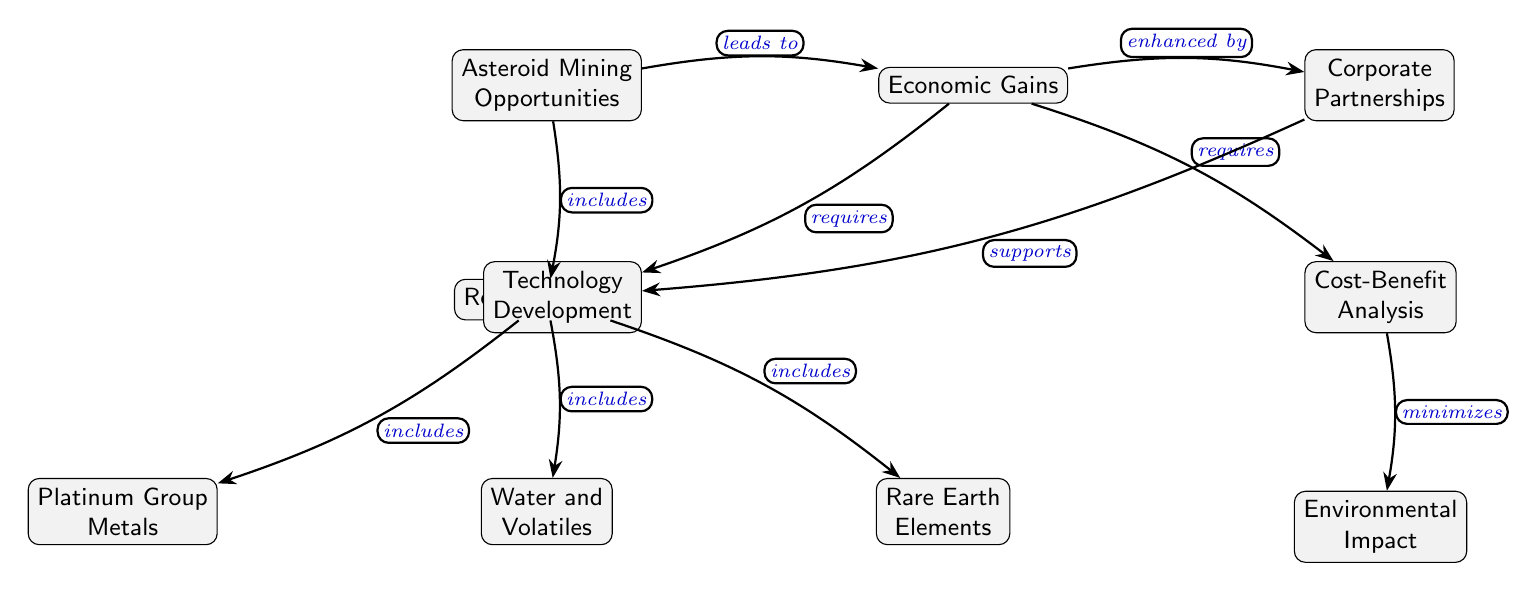What's included under Resource Types? The diagram shows three specific nodes below "Resource Types": Platinum Group Metals, Water and Volatiles, and Rare Earth Elements. They are directly connected to the Resource Types node, indicating they are included in this category.
Answer: Platinum Group Metals, Water and Volatiles, Rare Earth Elements How many resources are listed? The "Resource Types" node has three branches leading to different resources: Platinum Group Metals, Water and Volatiles, and Rare Earth Elements. Counting these branches gives us the total number of resource types listed.
Answer: 3 What does Asteroid Mining lead to? The diagram indicates a direct relationship where "Asteroid Mining Opportunities" leads to "Economic Gains." This is shown by an edge labeled "leads to" connecting these two nodes.
Answer: Economic Gains What requires Technology Development? According to the diagram, "Economic Gains" requires both "Cost-Benefit Analysis" and "Technology Development." Since the question specifically asks for what requires technology development, we can refer directly to the flow from "Economic Gains."
Answer: Economic Gains Which node supports Technology Development? The diagram shows a relationship where "Corporate Partnerships" enhances "Technology Development." The edge connecting these two nodes carries the label "supports," indicating that one assists the other.
Answer: Corporate Partnerships What minimizes Environmental Impact? The diagram indicates that "Cost-Benefit Analysis" minimizes "Environmental Impact." This relationship is shown by the edge labeled "minimizes" connecting both nodes, which reflects the process of improving outcomes while considering environmental factors.
Answer: Cost-Benefit Analysis What is one of the key resources mentioned directly related to Asteroid Mining? The diagram displays "Asteroid Mining Opportunities" leading to the "Resource Types" node, which includes "Platinum Group Metals," "Water and Volatiles," and "Rare Earth Elements." Therefore, referencing this flow, we can identify one key resource directly related to Asteroid Mining.
Answer: Platinum Group Metals Which strategy enhances Economic Gains? The diagram shows a direct relationship where "Corporate Partnerships" enhances "Economic Gains." The labeled connection indicates that forming these partnerships can lead to improved economic outcomes from asteroid mining ventures.
Answer: Corporate Partnerships 